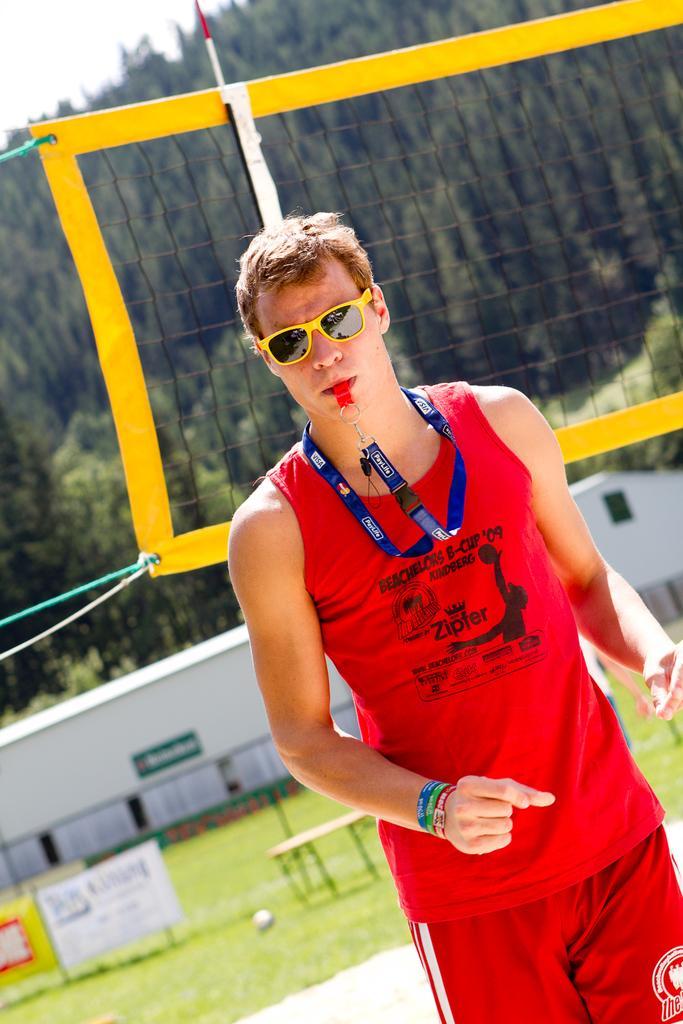How would you summarize this image in a sentence or two? In this picture we can observe a person wearing red color T shirt and a blue color tag in his neck. He is wearing yellow color framed spectacles. Behind him there is a net. In the background there are trees. We can observe some grass on the ground. 